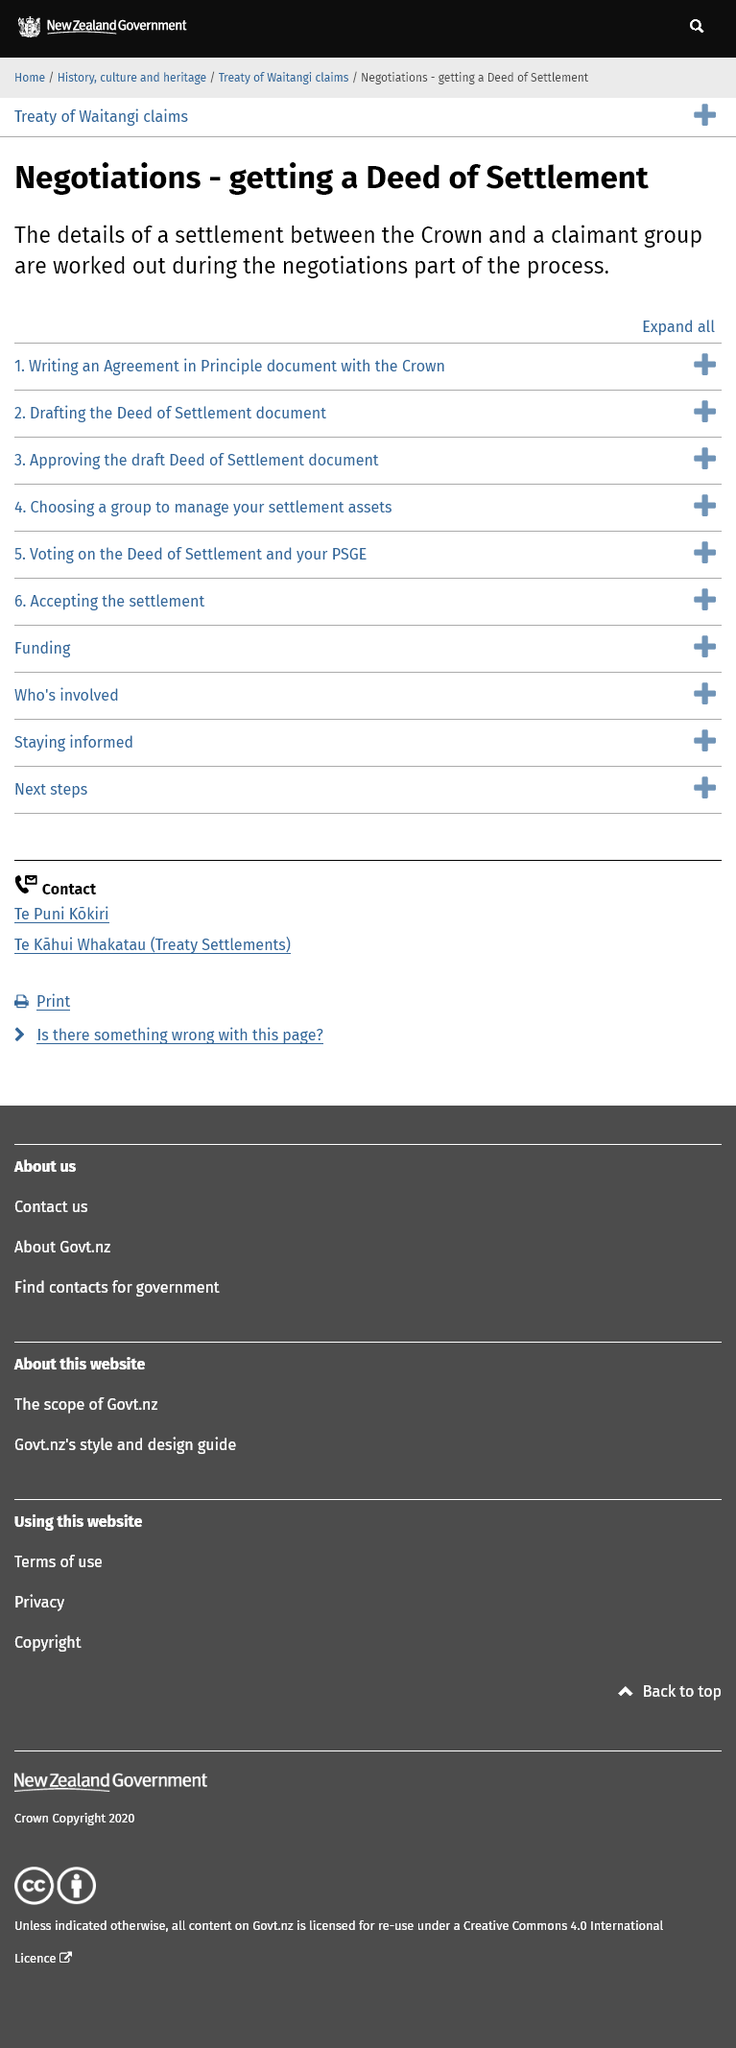Draw attention to some important aspects in this diagram. The first task involved in obtaining a deed of settlement is drafting an agreement in principle document with the Crown. The details of a deed settlement are sorted out during the negotiations part of the process. The negotiation of a deed settlement involves the crown and the claimant group. 